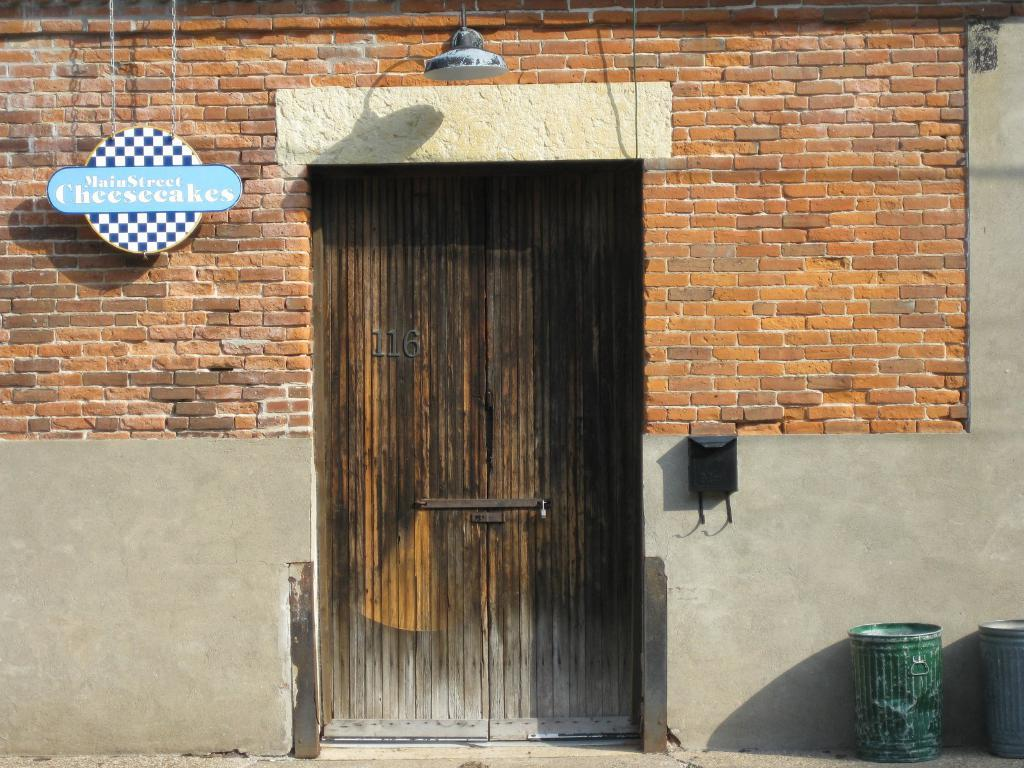What is present on the wall in the image? There is a board on the wall. What is the purpose of the board on the wall? The board on the wall has text on it, which suggests it might be used for displaying information or messages. What other features can be seen on the wall? There is a door in the wall. What objects are near the wall? There are two dustbins near the wall. What type of music can be heard coming from the dolls in the image? There are no dolls present in the image, so it is not possible to determine what type of music might be heard. 